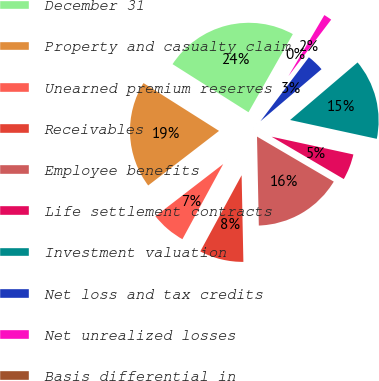Convert chart. <chart><loc_0><loc_0><loc_500><loc_500><pie_chart><fcel>December 31<fcel>Property and casualty claim<fcel>Unearned premium reserves<fcel>Receivables<fcel>Employee benefits<fcel>Life settlement contracts<fcel>Investment valuation<fcel>Net loss and tax credits<fcel>Net unrealized losses<fcel>Basis differential in<nl><fcel>24.23%<fcel>19.43%<fcel>6.64%<fcel>8.24%<fcel>16.23%<fcel>5.04%<fcel>14.64%<fcel>3.45%<fcel>1.85%<fcel>0.25%<nl></chart> 